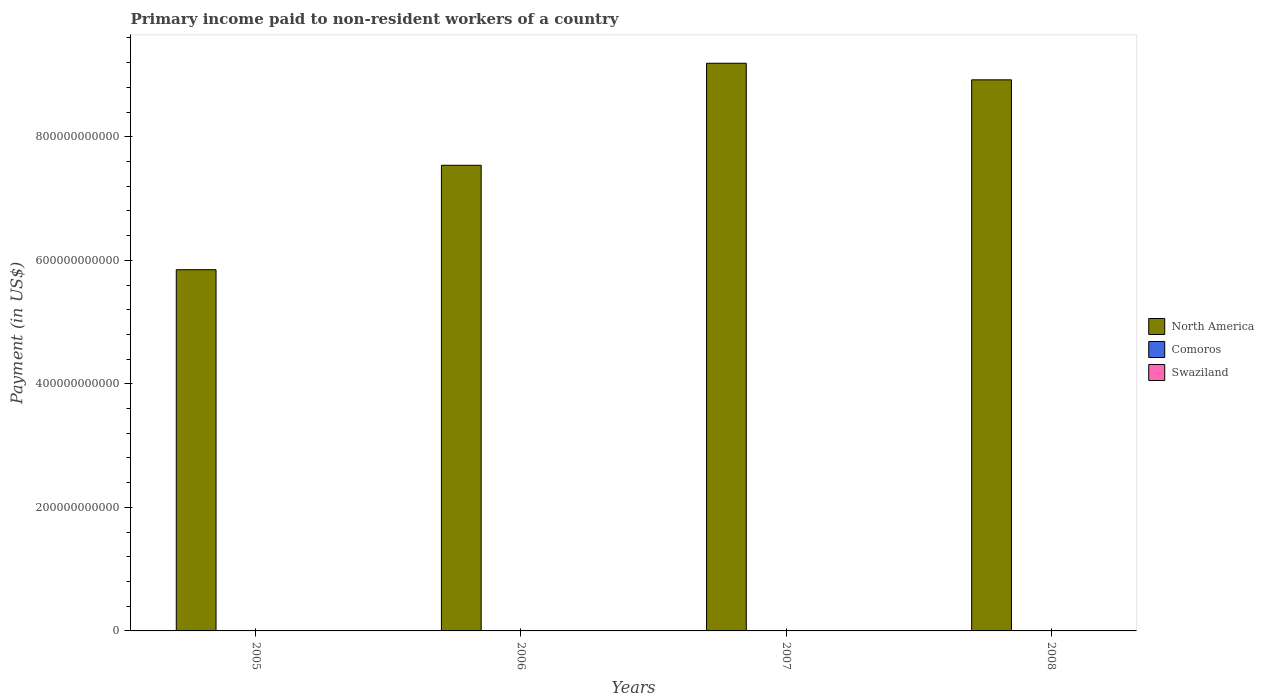How many groups of bars are there?
Provide a succinct answer. 4. How many bars are there on the 4th tick from the left?
Offer a very short reply. 3. What is the label of the 1st group of bars from the left?
Make the answer very short. 2005. What is the amount paid to workers in Comoros in 2005?
Your answer should be very brief. 2.44e+06. Across all years, what is the maximum amount paid to workers in North America?
Ensure brevity in your answer.  9.19e+11. Across all years, what is the minimum amount paid to workers in Swaziland?
Offer a very short reply. 2.42e+08. In which year was the amount paid to workers in North America minimum?
Make the answer very short. 2005. What is the total amount paid to workers in North America in the graph?
Ensure brevity in your answer.  3.15e+12. What is the difference between the amount paid to workers in North America in 2006 and that in 2008?
Make the answer very short. -1.38e+11. What is the difference between the amount paid to workers in Swaziland in 2008 and the amount paid to workers in Comoros in 2006?
Your answer should be compact. 2.95e+08. What is the average amount paid to workers in North America per year?
Give a very brief answer. 7.87e+11. In the year 2008, what is the difference between the amount paid to workers in Swaziland and amount paid to workers in North America?
Offer a terse response. -8.92e+11. What is the ratio of the amount paid to workers in Comoros in 2005 to that in 2006?
Your response must be concise. 0.72. Is the difference between the amount paid to workers in Swaziland in 2005 and 2006 greater than the difference between the amount paid to workers in North America in 2005 and 2006?
Your answer should be very brief. Yes. What is the difference between the highest and the second highest amount paid to workers in Swaziland?
Your answer should be very brief. 1.72e+07. What is the difference between the highest and the lowest amount paid to workers in Swaziland?
Provide a short and direct response. 5.63e+07. In how many years, is the amount paid to workers in North America greater than the average amount paid to workers in North America taken over all years?
Keep it short and to the point. 2. Is the sum of the amount paid to workers in Swaziland in 2005 and 2008 greater than the maximum amount paid to workers in Comoros across all years?
Keep it short and to the point. Yes. What does the 2nd bar from the left in 2008 represents?
Your answer should be compact. Comoros. What does the 1st bar from the right in 2007 represents?
Make the answer very short. Swaziland. How many bars are there?
Ensure brevity in your answer.  12. How many years are there in the graph?
Keep it short and to the point. 4. What is the difference between two consecutive major ticks on the Y-axis?
Your answer should be compact. 2.00e+11. Are the values on the major ticks of Y-axis written in scientific E-notation?
Keep it short and to the point. No. Does the graph contain any zero values?
Make the answer very short. No. Does the graph contain grids?
Make the answer very short. No. Where does the legend appear in the graph?
Provide a short and direct response. Center right. How are the legend labels stacked?
Your answer should be very brief. Vertical. What is the title of the graph?
Your response must be concise. Primary income paid to non-resident workers of a country. What is the label or title of the X-axis?
Offer a very short reply. Years. What is the label or title of the Y-axis?
Ensure brevity in your answer.  Payment (in US$). What is the Payment (in US$) in North America in 2005?
Keep it short and to the point. 5.85e+11. What is the Payment (in US$) in Comoros in 2005?
Offer a very short reply. 2.44e+06. What is the Payment (in US$) in Swaziland in 2005?
Offer a terse response. 2.71e+08. What is the Payment (in US$) in North America in 2006?
Ensure brevity in your answer.  7.54e+11. What is the Payment (in US$) in Comoros in 2006?
Make the answer very short. 3.37e+06. What is the Payment (in US$) in Swaziland in 2006?
Give a very brief answer. 2.42e+08. What is the Payment (in US$) of North America in 2007?
Keep it short and to the point. 9.19e+11. What is the Payment (in US$) in Comoros in 2007?
Offer a terse response. 5.32e+06. What is the Payment (in US$) in Swaziland in 2007?
Your answer should be very brief. 2.81e+08. What is the Payment (in US$) of North America in 2008?
Give a very brief answer. 8.92e+11. What is the Payment (in US$) of Comoros in 2008?
Make the answer very short. 5.55e+06. What is the Payment (in US$) in Swaziland in 2008?
Your response must be concise. 2.98e+08. Across all years, what is the maximum Payment (in US$) of North America?
Ensure brevity in your answer.  9.19e+11. Across all years, what is the maximum Payment (in US$) of Comoros?
Provide a short and direct response. 5.55e+06. Across all years, what is the maximum Payment (in US$) in Swaziland?
Your answer should be compact. 2.98e+08. Across all years, what is the minimum Payment (in US$) in North America?
Provide a succinct answer. 5.85e+11. Across all years, what is the minimum Payment (in US$) of Comoros?
Keep it short and to the point. 2.44e+06. Across all years, what is the minimum Payment (in US$) of Swaziland?
Your answer should be very brief. 2.42e+08. What is the total Payment (in US$) in North America in the graph?
Keep it short and to the point. 3.15e+12. What is the total Payment (in US$) in Comoros in the graph?
Your response must be concise. 1.67e+07. What is the total Payment (in US$) of Swaziland in the graph?
Provide a succinct answer. 1.09e+09. What is the difference between the Payment (in US$) in North America in 2005 and that in 2006?
Your answer should be very brief. -1.69e+11. What is the difference between the Payment (in US$) of Comoros in 2005 and that in 2006?
Your answer should be compact. -9.27e+05. What is the difference between the Payment (in US$) in Swaziland in 2005 and that in 2006?
Your answer should be compact. 2.96e+07. What is the difference between the Payment (in US$) of North America in 2005 and that in 2007?
Provide a short and direct response. -3.34e+11. What is the difference between the Payment (in US$) of Comoros in 2005 and that in 2007?
Keep it short and to the point. -2.87e+06. What is the difference between the Payment (in US$) of Swaziland in 2005 and that in 2007?
Make the answer very short. -9.55e+06. What is the difference between the Payment (in US$) in North America in 2005 and that in 2008?
Ensure brevity in your answer.  -3.07e+11. What is the difference between the Payment (in US$) in Comoros in 2005 and that in 2008?
Provide a short and direct response. -3.11e+06. What is the difference between the Payment (in US$) in Swaziland in 2005 and that in 2008?
Provide a short and direct response. -2.67e+07. What is the difference between the Payment (in US$) of North America in 2006 and that in 2007?
Your response must be concise. -1.65e+11. What is the difference between the Payment (in US$) of Comoros in 2006 and that in 2007?
Provide a short and direct response. -1.95e+06. What is the difference between the Payment (in US$) of Swaziland in 2006 and that in 2007?
Make the answer very short. -3.91e+07. What is the difference between the Payment (in US$) of North America in 2006 and that in 2008?
Offer a very short reply. -1.38e+11. What is the difference between the Payment (in US$) in Comoros in 2006 and that in 2008?
Provide a succinct answer. -2.18e+06. What is the difference between the Payment (in US$) in Swaziland in 2006 and that in 2008?
Ensure brevity in your answer.  -5.63e+07. What is the difference between the Payment (in US$) of North America in 2007 and that in 2008?
Your answer should be compact. 2.68e+1. What is the difference between the Payment (in US$) of Comoros in 2007 and that in 2008?
Offer a terse response. -2.30e+05. What is the difference between the Payment (in US$) of Swaziland in 2007 and that in 2008?
Make the answer very short. -1.72e+07. What is the difference between the Payment (in US$) in North America in 2005 and the Payment (in US$) in Comoros in 2006?
Ensure brevity in your answer.  5.85e+11. What is the difference between the Payment (in US$) of North America in 2005 and the Payment (in US$) of Swaziland in 2006?
Offer a very short reply. 5.85e+11. What is the difference between the Payment (in US$) of Comoros in 2005 and the Payment (in US$) of Swaziland in 2006?
Keep it short and to the point. -2.39e+08. What is the difference between the Payment (in US$) of North America in 2005 and the Payment (in US$) of Comoros in 2007?
Provide a short and direct response. 5.85e+11. What is the difference between the Payment (in US$) in North America in 2005 and the Payment (in US$) in Swaziland in 2007?
Offer a very short reply. 5.84e+11. What is the difference between the Payment (in US$) in Comoros in 2005 and the Payment (in US$) in Swaziland in 2007?
Provide a succinct answer. -2.78e+08. What is the difference between the Payment (in US$) in North America in 2005 and the Payment (in US$) in Comoros in 2008?
Your answer should be very brief. 5.85e+11. What is the difference between the Payment (in US$) in North America in 2005 and the Payment (in US$) in Swaziland in 2008?
Offer a very short reply. 5.84e+11. What is the difference between the Payment (in US$) of Comoros in 2005 and the Payment (in US$) of Swaziland in 2008?
Your answer should be very brief. -2.96e+08. What is the difference between the Payment (in US$) in North America in 2006 and the Payment (in US$) in Comoros in 2007?
Ensure brevity in your answer.  7.54e+11. What is the difference between the Payment (in US$) in North America in 2006 and the Payment (in US$) in Swaziland in 2007?
Give a very brief answer. 7.54e+11. What is the difference between the Payment (in US$) in Comoros in 2006 and the Payment (in US$) in Swaziland in 2007?
Provide a short and direct response. -2.77e+08. What is the difference between the Payment (in US$) in North America in 2006 and the Payment (in US$) in Comoros in 2008?
Make the answer very short. 7.54e+11. What is the difference between the Payment (in US$) in North America in 2006 and the Payment (in US$) in Swaziland in 2008?
Keep it short and to the point. 7.54e+11. What is the difference between the Payment (in US$) in Comoros in 2006 and the Payment (in US$) in Swaziland in 2008?
Keep it short and to the point. -2.95e+08. What is the difference between the Payment (in US$) of North America in 2007 and the Payment (in US$) of Comoros in 2008?
Your response must be concise. 9.19e+11. What is the difference between the Payment (in US$) in North America in 2007 and the Payment (in US$) in Swaziland in 2008?
Offer a very short reply. 9.19e+11. What is the difference between the Payment (in US$) of Comoros in 2007 and the Payment (in US$) of Swaziland in 2008?
Your answer should be very brief. -2.93e+08. What is the average Payment (in US$) of North America per year?
Your response must be concise. 7.87e+11. What is the average Payment (in US$) of Comoros per year?
Your answer should be compact. 4.17e+06. What is the average Payment (in US$) of Swaziland per year?
Your answer should be compact. 2.73e+08. In the year 2005, what is the difference between the Payment (in US$) of North America and Payment (in US$) of Comoros?
Provide a succinct answer. 5.85e+11. In the year 2005, what is the difference between the Payment (in US$) of North America and Payment (in US$) of Swaziland?
Your answer should be very brief. 5.85e+11. In the year 2005, what is the difference between the Payment (in US$) in Comoros and Payment (in US$) in Swaziland?
Offer a terse response. -2.69e+08. In the year 2006, what is the difference between the Payment (in US$) in North America and Payment (in US$) in Comoros?
Give a very brief answer. 7.54e+11. In the year 2006, what is the difference between the Payment (in US$) in North America and Payment (in US$) in Swaziland?
Keep it short and to the point. 7.54e+11. In the year 2006, what is the difference between the Payment (in US$) in Comoros and Payment (in US$) in Swaziland?
Offer a very short reply. -2.38e+08. In the year 2007, what is the difference between the Payment (in US$) in North America and Payment (in US$) in Comoros?
Your answer should be very brief. 9.19e+11. In the year 2007, what is the difference between the Payment (in US$) in North America and Payment (in US$) in Swaziland?
Make the answer very short. 9.19e+11. In the year 2007, what is the difference between the Payment (in US$) in Comoros and Payment (in US$) in Swaziland?
Your answer should be very brief. -2.76e+08. In the year 2008, what is the difference between the Payment (in US$) in North America and Payment (in US$) in Comoros?
Provide a short and direct response. 8.92e+11. In the year 2008, what is the difference between the Payment (in US$) in North America and Payment (in US$) in Swaziland?
Your response must be concise. 8.92e+11. In the year 2008, what is the difference between the Payment (in US$) of Comoros and Payment (in US$) of Swaziland?
Offer a terse response. -2.92e+08. What is the ratio of the Payment (in US$) in North America in 2005 to that in 2006?
Give a very brief answer. 0.78. What is the ratio of the Payment (in US$) of Comoros in 2005 to that in 2006?
Your response must be concise. 0.72. What is the ratio of the Payment (in US$) in Swaziland in 2005 to that in 2006?
Ensure brevity in your answer.  1.12. What is the ratio of the Payment (in US$) of North America in 2005 to that in 2007?
Offer a terse response. 0.64. What is the ratio of the Payment (in US$) of Comoros in 2005 to that in 2007?
Your answer should be very brief. 0.46. What is the ratio of the Payment (in US$) in Swaziland in 2005 to that in 2007?
Your answer should be compact. 0.97. What is the ratio of the Payment (in US$) of North America in 2005 to that in 2008?
Offer a very short reply. 0.66. What is the ratio of the Payment (in US$) in Comoros in 2005 to that in 2008?
Offer a terse response. 0.44. What is the ratio of the Payment (in US$) in Swaziland in 2005 to that in 2008?
Provide a succinct answer. 0.91. What is the ratio of the Payment (in US$) of North America in 2006 to that in 2007?
Your answer should be very brief. 0.82. What is the ratio of the Payment (in US$) of Comoros in 2006 to that in 2007?
Your answer should be very brief. 0.63. What is the ratio of the Payment (in US$) of Swaziland in 2006 to that in 2007?
Keep it short and to the point. 0.86. What is the ratio of the Payment (in US$) in North America in 2006 to that in 2008?
Ensure brevity in your answer.  0.84. What is the ratio of the Payment (in US$) in Comoros in 2006 to that in 2008?
Your answer should be compact. 0.61. What is the ratio of the Payment (in US$) in Swaziland in 2006 to that in 2008?
Offer a terse response. 0.81. What is the ratio of the Payment (in US$) of North America in 2007 to that in 2008?
Make the answer very short. 1.03. What is the ratio of the Payment (in US$) of Comoros in 2007 to that in 2008?
Your answer should be compact. 0.96. What is the ratio of the Payment (in US$) in Swaziland in 2007 to that in 2008?
Your answer should be compact. 0.94. What is the difference between the highest and the second highest Payment (in US$) of North America?
Your answer should be very brief. 2.68e+1. What is the difference between the highest and the second highest Payment (in US$) in Comoros?
Provide a succinct answer. 2.30e+05. What is the difference between the highest and the second highest Payment (in US$) in Swaziland?
Your answer should be very brief. 1.72e+07. What is the difference between the highest and the lowest Payment (in US$) of North America?
Offer a very short reply. 3.34e+11. What is the difference between the highest and the lowest Payment (in US$) of Comoros?
Give a very brief answer. 3.11e+06. What is the difference between the highest and the lowest Payment (in US$) in Swaziland?
Provide a succinct answer. 5.63e+07. 